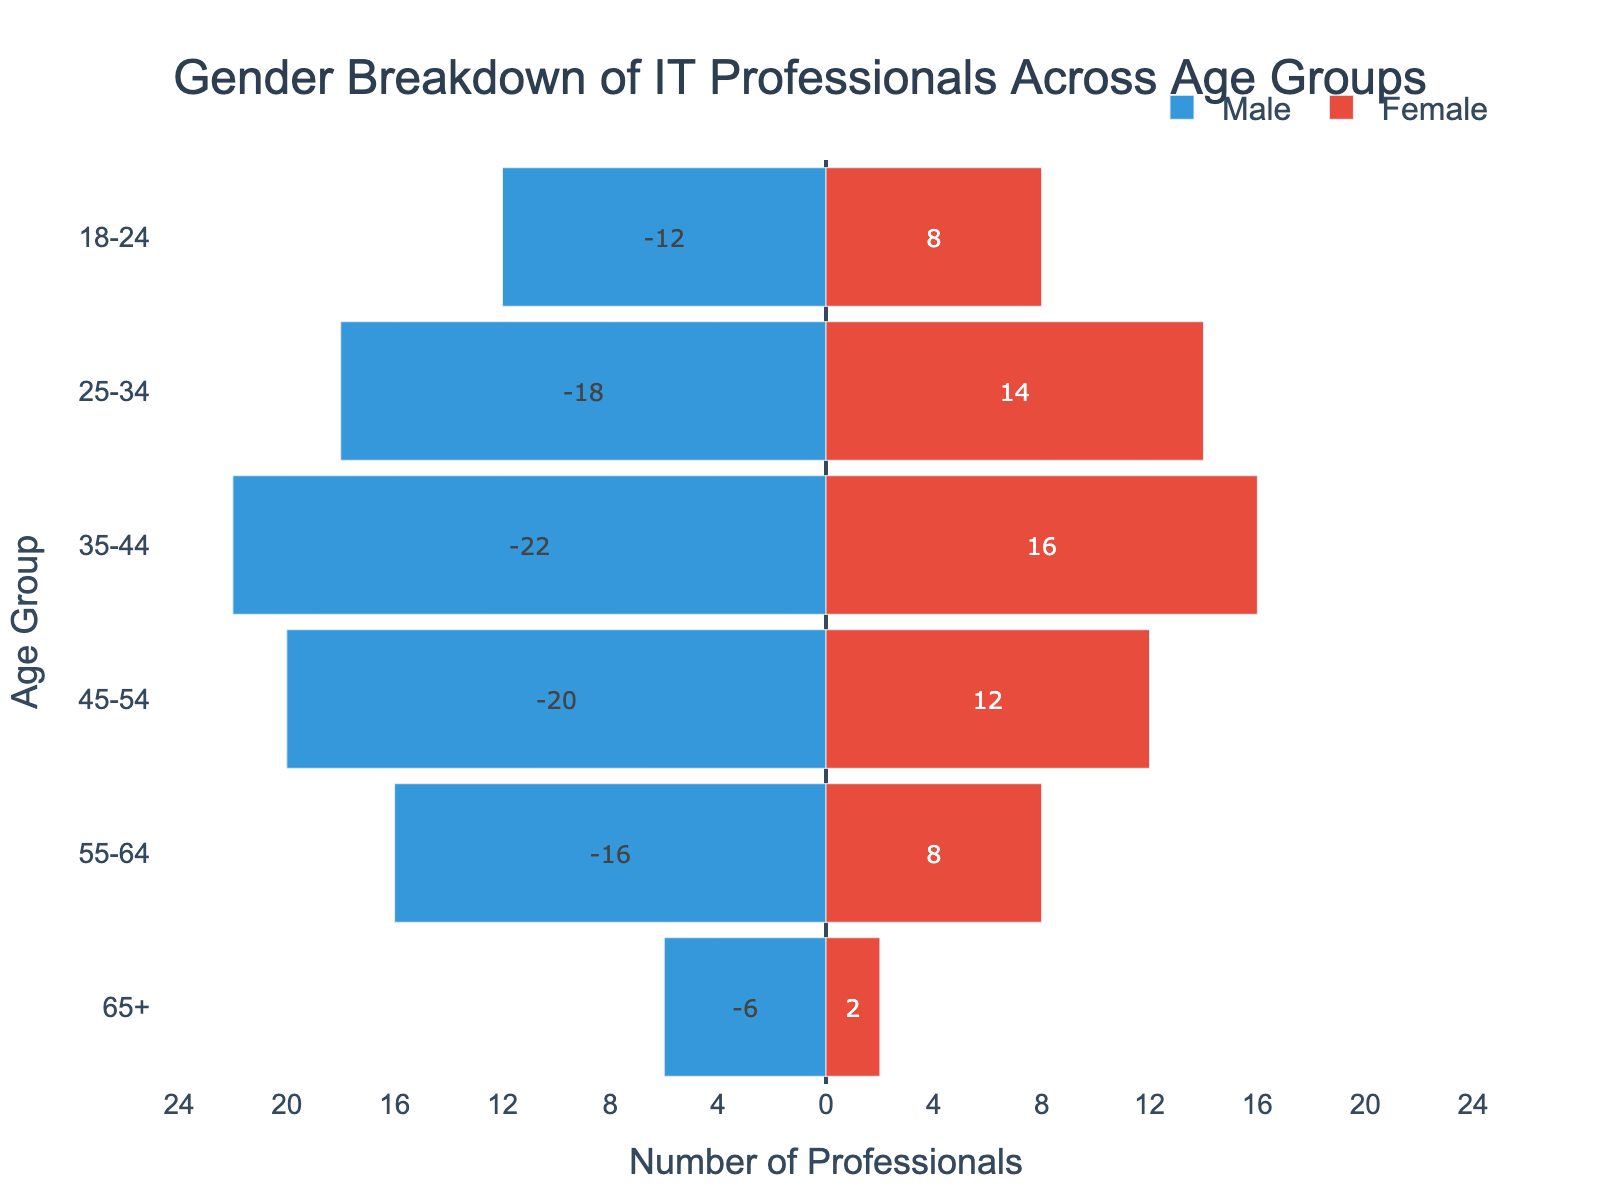What is the title of the figure? The title is always displayed at the top of the figure. Here, it reads "Gender Breakdown of IT Professionals Across Age Groups."
Answer: Gender Breakdown of IT Professionals Across Age Groups How many age groups are presented in the figure? By counting the unique categories along the y-axis, we can see there are six age groups listed: 18-24, 25-34, 35-44, 45-54, 55-64, and 65+.
Answer: Six Which age group has the highest number of male IT professionals? Look for the bar that extends the farthest to the left (negative x-axis). The age group 35-44 has the most extended bar in the male section.
Answer: 35-44 What is the total number of female IT professionals in the 25-34 and 35-44 age groups combined? To find the total, add the values for females in these age groups: 14 (25-34) + 16 (35-44) = 30.
Answer: 30 Are there more male or female IT professionals in the 55-64 age group? Compare the lengths of the bars for male and female in this age group; the male bar is longer (16 vs. 8).
Answer: Male Which age group has the smallest gender disparity? The smallest disparity is where the bars for male and female are closest in length. For the 18-24 age group, the male count is 12, and the female count is 8, making a difference of 4, which is the smallest among all categories.
Answer: 18-24 What is the total number of IT professionals in the 45-54 age group? Add the male and female values for this age group: 20 (male) + 12 (female) = 32.
Answer: 32 How many more male IT professionals are there compared to female IT professionals in the 35-44 age group? Subtract the number of females from the number of males in the 35-44 age group: 22 - 16 = 6.
Answer: 6 Which gender is more represented in the 65+ age group? Compare the length of the male and female bars in this age group. The male bar is longer (6 vs. 2).
Answer: Male If the bars for the female IT professionals were all doubled in length, which age group would have the highest female count? Doubling the female values would: 8 (18-24) -> 16, 14 (25-34) -> 28, 16 (35-44) -> 32, 12 (45-54) -> 24, 8 (55-64) -> 16, and 2 (65+) -> 4. The 35-44 age group would have the highest value (32).
Answer: 35-44 